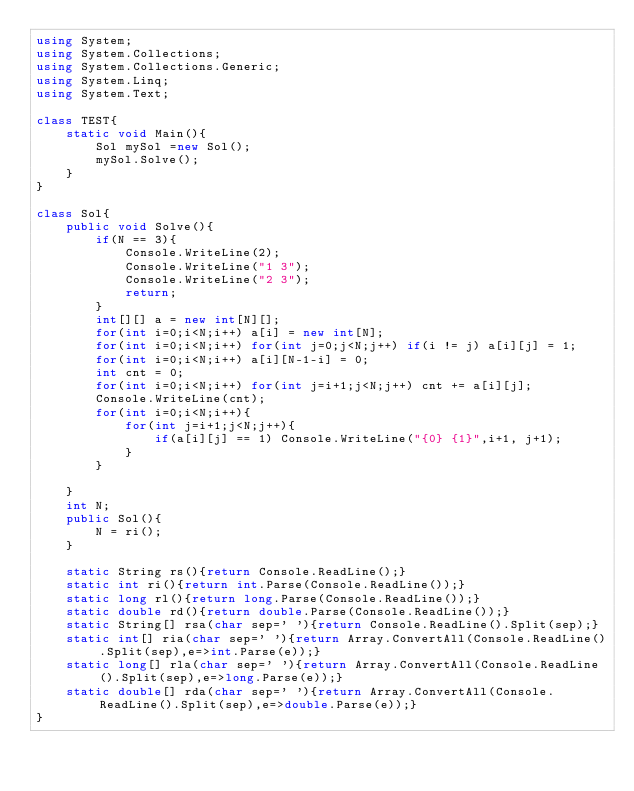<code> <loc_0><loc_0><loc_500><loc_500><_C#_>using System;
using System.Collections;
using System.Collections.Generic;
using System.Linq;
using System.Text;

class TEST{
	static void Main(){
		Sol mySol =new Sol();
		mySol.Solve();
	}
}

class Sol{
	public void Solve(){
		if(N == 3){
			Console.WriteLine(2);
			Console.WriteLine("1 3");
			Console.WriteLine("2 3");
			return;
		}
		int[][] a = new int[N][];
		for(int i=0;i<N;i++) a[i] = new int[N];
		for(int i=0;i<N;i++) for(int j=0;j<N;j++) if(i != j) a[i][j] = 1;
		for(int i=0;i<N;i++) a[i][N-1-i] = 0;
		int cnt = 0;
		for(int i=0;i<N;i++) for(int j=i+1;j<N;j++) cnt += a[i][j];
		Console.WriteLine(cnt);
		for(int i=0;i<N;i++){
			for(int j=i+1;j<N;j++){
				if(a[i][j] == 1) Console.WriteLine("{0} {1}",i+1, j+1);
			}
		}
		
	}
	int N;
	public Sol(){
		N = ri();
	}

	static String rs(){return Console.ReadLine();}
	static int ri(){return int.Parse(Console.ReadLine());}
	static long rl(){return long.Parse(Console.ReadLine());}
	static double rd(){return double.Parse(Console.ReadLine());}
	static String[] rsa(char sep=' '){return Console.ReadLine().Split(sep);}
	static int[] ria(char sep=' '){return Array.ConvertAll(Console.ReadLine().Split(sep),e=>int.Parse(e));}
	static long[] rla(char sep=' '){return Array.ConvertAll(Console.ReadLine().Split(sep),e=>long.Parse(e));}
	static double[] rda(char sep=' '){return Array.ConvertAll(Console.ReadLine().Split(sep),e=>double.Parse(e));}
}
</code> 